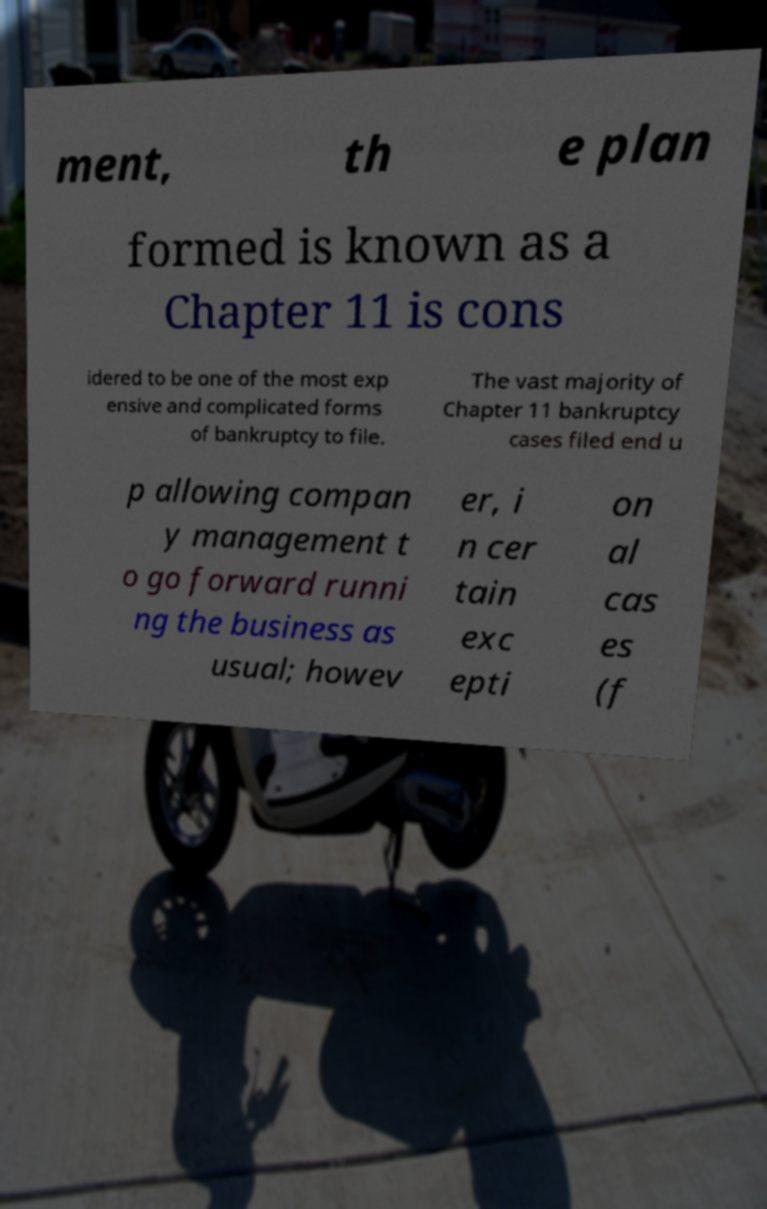Can you accurately transcribe the text from the provided image for me? ment, th e plan formed is known as a Chapter 11 is cons idered to be one of the most exp ensive and complicated forms of bankruptcy to file. The vast majority of Chapter 11 bankruptcy cases filed end u p allowing compan y management t o go forward runni ng the business as usual; howev er, i n cer tain exc epti on al cas es (f 